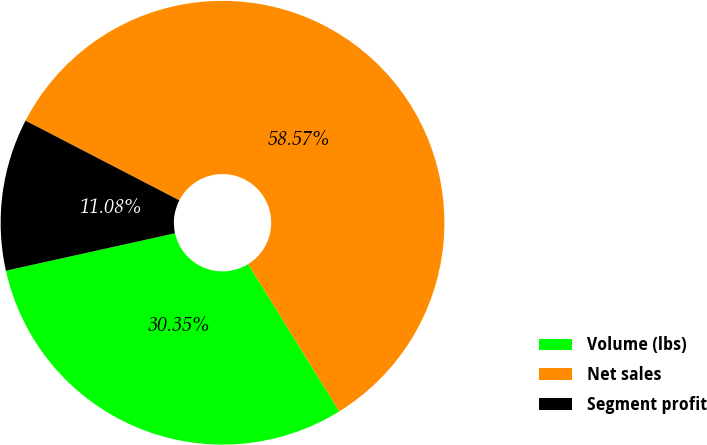<chart> <loc_0><loc_0><loc_500><loc_500><pie_chart><fcel>Volume (lbs)<fcel>Net sales<fcel>Segment profit<nl><fcel>30.35%<fcel>58.57%<fcel>11.08%<nl></chart> 